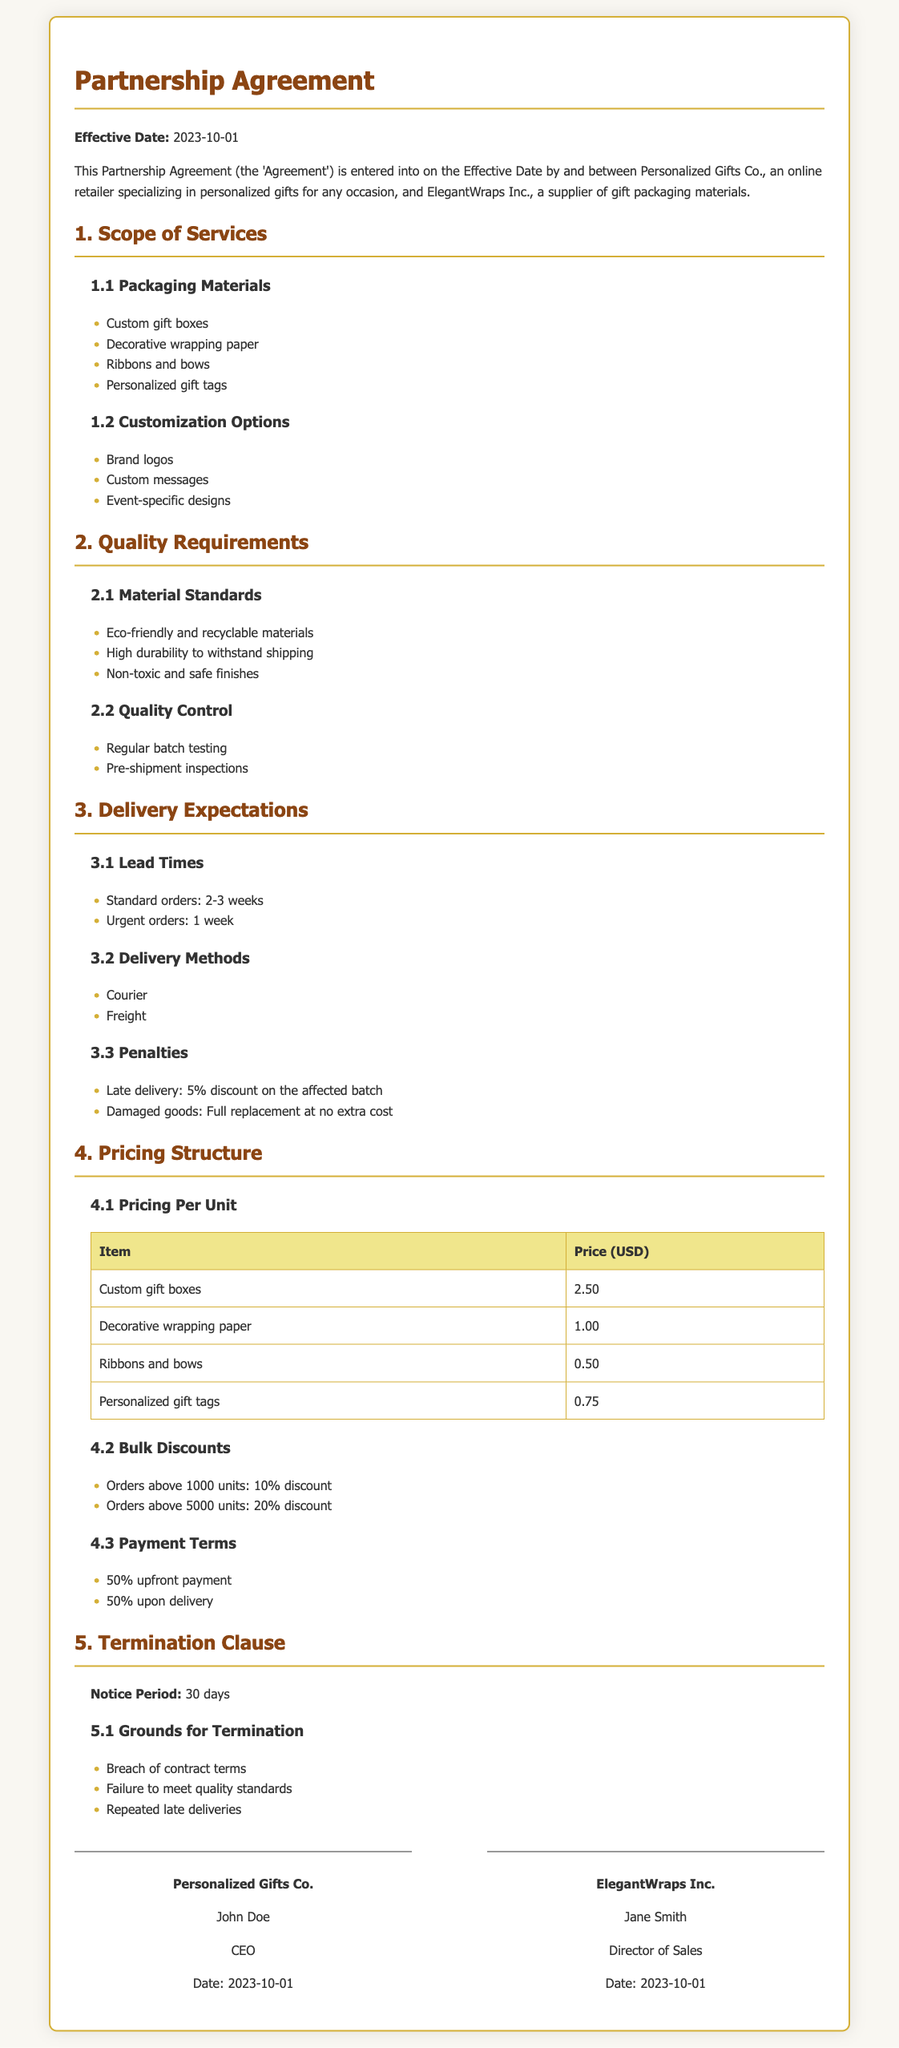What is the effective date of the agreement? The effective date is stated in the opening paragraph of the document.
Answer: 2023-10-01 What company is specified as the packaging supplier? The document explicitly states the name of the supplier in the introduction.
Answer: ElegantWraps Inc What type of packaging materials are mentioned in the scope of services? The document lists the types of packaging materials in section 1.1.
Answer: Custom gift boxes, Decorative wrapping paper, Ribbons and bows, Personalized gift tags What is the penalty for late delivery? The penalties for late delivery are listed in section 3.3 under "Penalties."
Answer: 5% discount on the affected batch What is the price of personalized gift tags per unit? The pricing information can be found in section 4.1 in the table provided.
Answer: 0.75 How many days is the notice period for termination? The notice period is specified in section 5.
Answer: 30 days What are the bulk discount percentages for orders above 5000 units? The bulk discounts are highlighted in section 4.2.
Answer: 20% discount What customization option is listed for gift packaging? Customization options are detailed in section 1.2.
Answer: Brand logos What is required for the material standards? Material standards are outlined in section 2.1 of the document.
Answer: Eco-friendly and recyclable materials, High durability to withstand shipping, Non-toxic and safe finishes 